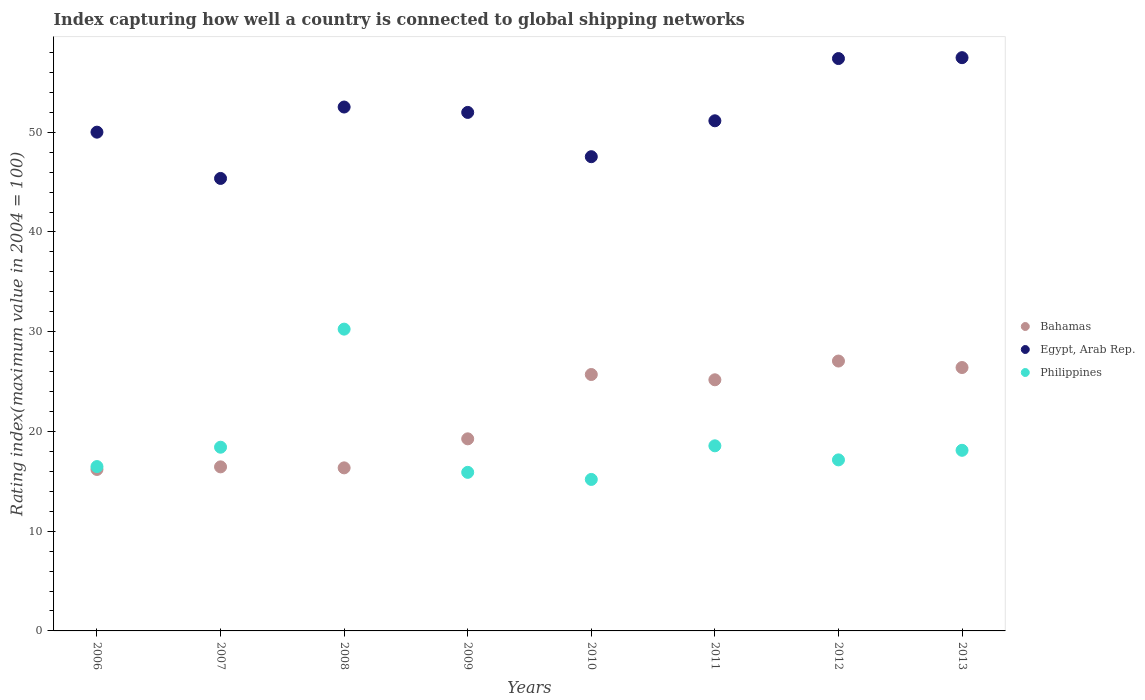What is the rating index in Philippines in 2006?
Your answer should be very brief. 16.48. Across all years, what is the maximum rating index in Bahamas?
Your answer should be compact. 27.06. Across all years, what is the minimum rating index in Philippines?
Your answer should be compact. 15.19. What is the total rating index in Philippines in the graph?
Your answer should be compact. 150.07. What is the difference between the rating index in Egypt, Arab Rep. in 2007 and that in 2010?
Make the answer very short. -2.18. What is the difference between the rating index in Philippines in 2011 and the rating index in Bahamas in 2010?
Make the answer very short. -7.15. What is the average rating index in Philippines per year?
Make the answer very short. 18.76. In the year 2011, what is the difference between the rating index in Philippines and rating index in Egypt, Arab Rep.?
Keep it short and to the point. -32.59. In how many years, is the rating index in Philippines greater than 30?
Give a very brief answer. 1. What is the ratio of the rating index in Philippines in 2007 to that in 2011?
Offer a terse response. 0.99. Is the rating index in Philippines in 2006 less than that in 2011?
Your response must be concise. Yes. Is the difference between the rating index in Philippines in 2008 and 2009 greater than the difference between the rating index in Egypt, Arab Rep. in 2008 and 2009?
Your answer should be compact. Yes. What is the difference between the highest and the second highest rating index in Philippines?
Provide a short and direct response. 11.7. What is the difference between the highest and the lowest rating index in Philippines?
Ensure brevity in your answer.  15.07. In how many years, is the rating index in Egypt, Arab Rep. greater than the average rating index in Egypt, Arab Rep. taken over all years?
Offer a very short reply. 4. Is it the case that in every year, the sum of the rating index in Egypt, Arab Rep. and rating index in Bahamas  is greater than the rating index in Philippines?
Keep it short and to the point. Yes. Does the rating index in Bahamas monotonically increase over the years?
Provide a short and direct response. No. What is the difference between two consecutive major ticks on the Y-axis?
Offer a terse response. 10. Does the graph contain any zero values?
Your response must be concise. No. Does the graph contain grids?
Provide a short and direct response. No. Where does the legend appear in the graph?
Make the answer very short. Center right. What is the title of the graph?
Provide a succinct answer. Index capturing how well a country is connected to global shipping networks. What is the label or title of the X-axis?
Ensure brevity in your answer.  Years. What is the label or title of the Y-axis?
Give a very brief answer. Rating index(maximum value in 2004 = 100). What is the Rating index(maximum value in 2004 = 100) of Bahamas in 2006?
Your response must be concise. 16.19. What is the Rating index(maximum value in 2004 = 100) in Egypt, Arab Rep. in 2006?
Provide a succinct answer. 50.01. What is the Rating index(maximum value in 2004 = 100) of Philippines in 2006?
Your answer should be very brief. 16.48. What is the Rating index(maximum value in 2004 = 100) in Bahamas in 2007?
Offer a very short reply. 16.45. What is the Rating index(maximum value in 2004 = 100) in Egypt, Arab Rep. in 2007?
Offer a terse response. 45.37. What is the Rating index(maximum value in 2004 = 100) of Philippines in 2007?
Your response must be concise. 18.42. What is the Rating index(maximum value in 2004 = 100) of Bahamas in 2008?
Provide a succinct answer. 16.35. What is the Rating index(maximum value in 2004 = 100) of Egypt, Arab Rep. in 2008?
Make the answer very short. 52.53. What is the Rating index(maximum value in 2004 = 100) of Philippines in 2008?
Provide a short and direct response. 30.26. What is the Rating index(maximum value in 2004 = 100) in Bahamas in 2009?
Provide a short and direct response. 19.26. What is the Rating index(maximum value in 2004 = 100) in Egypt, Arab Rep. in 2009?
Offer a very short reply. 51.99. What is the Rating index(maximum value in 2004 = 100) of Bahamas in 2010?
Provide a succinct answer. 25.71. What is the Rating index(maximum value in 2004 = 100) in Egypt, Arab Rep. in 2010?
Your response must be concise. 47.55. What is the Rating index(maximum value in 2004 = 100) of Philippines in 2010?
Ensure brevity in your answer.  15.19. What is the Rating index(maximum value in 2004 = 100) of Bahamas in 2011?
Keep it short and to the point. 25.18. What is the Rating index(maximum value in 2004 = 100) in Egypt, Arab Rep. in 2011?
Provide a short and direct response. 51.15. What is the Rating index(maximum value in 2004 = 100) of Philippines in 2011?
Ensure brevity in your answer.  18.56. What is the Rating index(maximum value in 2004 = 100) in Bahamas in 2012?
Your answer should be very brief. 27.06. What is the Rating index(maximum value in 2004 = 100) of Egypt, Arab Rep. in 2012?
Offer a very short reply. 57.39. What is the Rating index(maximum value in 2004 = 100) in Philippines in 2012?
Provide a succinct answer. 17.15. What is the Rating index(maximum value in 2004 = 100) in Bahamas in 2013?
Your answer should be compact. 26.41. What is the Rating index(maximum value in 2004 = 100) in Egypt, Arab Rep. in 2013?
Your response must be concise. 57.48. What is the Rating index(maximum value in 2004 = 100) in Philippines in 2013?
Offer a very short reply. 18.11. Across all years, what is the maximum Rating index(maximum value in 2004 = 100) of Bahamas?
Ensure brevity in your answer.  27.06. Across all years, what is the maximum Rating index(maximum value in 2004 = 100) of Egypt, Arab Rep.?
Your response must be concise. 57.48. Across all years, what is the maximum Rating index(maximum value in 2004 = 100) in Philippines?
Give a very brief answer. 30.26. Across all years, what is the minimum Rating index(maximum value in 2004 = 100) in Bahamas?
Provide a short and direct response. 16.19. Across all years, what is the minimum Rating index(maximum value in 2004 = 100) of Egypt, Arab Rep.?
Your response must be concise. 45.37. Across all years, what is the minimum Rating index(maximum value in 2004 = 100) in Philippines?
Offer a terse response. 15.19. What is the total Rating index(maximum value in 2004 = 100) in Bahamas in the graph?
Give a very brief answer. 172.61. What is the total Rating index(maximum value in 2004 = 100) of Egypt, Arab Rep. in the graph?
Keep it short and to the point. 413.47. What is the total Rating index(maximum value in 2004 = 100) of Philippines in the graph?
Offer a very short reply. 150.07. What is the difference between the Rating index(maximum value in 2004 = 100) in Bahamas in 2006 and that in 2007?
Give a very brief answer. -0.26. What is the difference between the Rating index(maximum value in 2004 = 100) of Egypt, Arab Rep. in 2006 and that in 2007?
Your answer should be compact. 4.64. What is the difference between the Rating index(maximum value in 2004 = 100) in Philippines in 2006 and that in 2007?
Your response must be concise. -1.94. What is the difference between the Rating index(maximum value in 2004 = 100) of Bahamas in 2006 and that in 2008?
Offer a terse response. -0.16. What is the difference between the Rating index(maximum value in 2004 = 100) in Egypt, Arab Rep. in 2006 and that in 2008?
Keep it short and to the point. -2.52. What is the difference between the Rating index(maximum value in 2004 = 100) of Philippines in 2006 and that in 2008?
Your answer should be compact. -13.78. What is the difference between the Rating index(maximum value in 2004 = 100) in Bahamas in 2006 and that in 2009?
Keep it short and to the point. -3.07. What is the difference between the Rating index(maximum value in 2004 = 100) in Egypt, Arab Rep. in 2006 and that in 2009?
Provide a succinct answer. -1.98. What is the difference between the Rating index(maximum value in 2004 = 100) of Philippines in 2006 and that in 2009?
Make the answer very short. 0.58. What is the difference between the Rating index(maximum value in 2004 = 100) in Bahamas in 2006 and that in 2010?
Make the answer very short. -9.52. What is the difference between the Rating index(maximum value in 2004 = 100) of Egypt, Arab Rep. in 2006 and that in 2010?
Offer a very short reply. 2.46. What is the difference between the Rating index(maximum value in 2004 = 100) of Philippines in 2006 and that in 2010?
Your response must be concise. 1.29. What is the difference between the Rating index(maximum value in 2004 = 100) of Bahamas in 2006 and that in 2011?
Your answer should be compact. -8.99. What is the difference between the Rating index(maximum value in 2004 = 100) in Egypt, Arab Rep. in 2006 and that in 2011?
Your response must be concise. -1.14. What is the difference between the Rating index(maximum value in 2004 = 100) of Philippines in 2006 and that in 2011?
Your answer should be compact. -2.08. What is the difference between the Rating index(maximum value in 2004 = 100) in Bahamas in 2006 and that in 2012?
Offer a very short reply. -10.87. What is the difference between the Rating index(maximum value in 2004 = 100) in Egypt, Arab Rep. in 2006 and that in 2012?
Make the answer very short. -7.38. What is the difference between the Rating index(maximum value in 2004 = 100) in Philippines in 2006 and that in 2012?
Offer a very short reply. -0.67. What is the difference between the Rating index(maximum value in 2004 = 100) of Bahamas in 2006 and that in 2013?
Your response must be concise. -10.22. What is the difference between the Rating index(maximum value in 2004 = 100) of Egypt, Arab Rep. in 2006 and that in 2013?
Keep it short and to the point. -7.47. What is the difference between the Rating index(maximum value in 2004 = 100) of Philippines in 2006 and that in 2013?
Provide a short and direct response. -1.63. What is the difference between the Rating index(maximum value in 2004 = 100) of Bahamas in 2007 and that in 2008?
Provide a succinct answer. 0.1. What is the difference between the Rating index(maximum value in 2004 = 100) of Egypt, Arab Rep. in 2007 and that in 2008?
Ensure brevity in your answer.  -7.16. What is the difference between the Rating index(maximum value in 2004 = 100) in Philippines in 2007 and that in 2008?
Keep it short and to the point. -11.84. What is the difference between the Rating index(maximum value in 2004 = 100) in Bahamas in 2007 and that in 2009?
Provide a short and direct response. -2.81. What is the difference between the Rating index(maximum value in 2004 = 100) of Egypt, Arab Rep. in 2007 and that in 2009?
Give a very brief answer. -6.62. What is the difference between the Rating index(maximum value in 2004 = 100) of Philippines in 2007 and that in 2009?
Keep it short and to the point. 2.52. What is the difference between the Rating index(maximum value in 2004 = 100) in Bahamas in 2007 and that in 2010?
Keep it short and to the point. -9.26. What is the difference between the Rating index(maximum value in 2004 = 100) of Egypt, Arab Rep. in 2007 and that in 2010?
Provide a short and direct response. -2.18. What is the difference between the Rating index(maximum value in 2004 = 100) in Philippines in 2007 and that in 2010?
Offer a very short reply. 3.23. What is the difference between the Rating index(maximum value in 2004 = 100) in Bahamas in 2007 and that in 2011?
Your answer should be compact. -8.73. What is the difference between the Rating index(maximum value in 2004 = 100) of Egypt, Arab Rep. in 2007 and that in 2011?
Your response must be concise. -5.78. What is the difference between the Rating index(maximum value in 2004 = 100) in Philippines in 2007 and that in 2011?
Offer a very short reply. -0.14. What is the difference between the Rating index(maximum value in 2004 = 100) of Bahamas in 2007 and that in 2012?
Make the answer very short. -10.61. What is the difference between the Rating index(maximum value in 2004 = 100) of Egypt, Arab Rep. in 2007 and that in 2012?
Your response must be concise. -12.02. What is the difference between the Rating index(maximum value in 2004 = 100) of Philippines in 2007 and that in 2012?
Keep it short and to the point. 1.27. What is the difference between the Rating index(maximum value in 2004 = 100) in Bahamas in 2007 and that in 2013?
Provide a succinct answer. -9.96. What is the difference between the Rating index(maximum value in 2004 = 100) of Egypt, Arab Rep. in 2007 and that in 2013?
Ensure brevity in your answer.  -12.11. What is the difference between the Rating index(maximum value in 2004 = 100) in Philippines in 2007 and that in 2013?
Your answer should be compact. 0.31. What is the difference between the Rating index(maximum value in 2004 = 100) in Bahamas in 2008 and that in 2009?
Offer a terse response. -2.91. What is the difference between the Rating index(maximum value in 2004 = 100) in Egypt, Arab Rep. in 2008 and that in 2009?
Provide a short and direct response. 0.54. What is the difference between the Rating index(maximum value in 2004 = 100) in Philippines in 2008 and that in 2009?
Offer a very short reply. 14.36. What is the difference between the Rating index(maximum value in 2004 = 100) in Bahamas in 2008 and that in 2010?
Provide a short and direct response. -9.36. What is the difference between the Rating index(maximum value in 2004 = 100) in Egypt, Arab Rep. in 2008 and that in 2010?
Give a very brief answer. 4.98. What is the difference between the Rating index(maximum value in 2004 = 100) in Philippines in 2008 and that in 2010?
Offer a terse response. 15.07. What is the difference between the Rating index(maximum value in 2004 = 100) of Bahamas in 2008 and that in 2011?
Ensure brevity in your answer.  -8.83. What is the difference between the Rating index(maximum value in 2004 = 100) of Egypt, Arab Rep. in 2008 and that in 2011?
Your answer should be compact. 1.38. What is the difference between the Rating index(maximum value in 2004 = 100) of Philippines in 2008 and that in 2011?
Your answer should be very brief. 11.7. What is the difference between the Rating index(maximum value in 2004 = 100) of Bahamas in 2008 and that in 2012?
Make the answer very short. -10.71. What is the difference between the Rating index(maximum value in 2004 = 100) of Egypt, Arab Rep. in 2008 and that in 2012?
Your answer should be very brief. -4.86. What is the difference between the Rating index(maximum value in 2004 = 100) of Philippines in 2008 and that in 2012?
Offer a terse response. 13.11. What is the difference between the Rating index(maximum value in 2004 = 100) of Bahamas in 2008 and that in 2013?
Keep it short and to the point. -10.06. What is the difference between the Rating index(maximum value in 2004 = 100) in Egypt, Arab Rep. in 2008 and that in 2013?
Your answer should be compact. -4.95. What is the difference between the Rating index(maximum value in 2004 = 100) of Philippines in 2008 and that in 2013?
Provide a succinct answer. 12.15. What is the difference between the Rating index(maximum value in 2004 = 100) of Bahamas in 2009 and that in 2010?
Give a very brief answer. -6.45. What is the difference between the Rating index(maximum value in 2004 = 100) of Egypt, Arab Rep. in 2009 and that in 2010?
Provide a succinct answer. 4.44. What is the difference between the Rating index(maximum value in 2004 = 100) of Philippines in 2009 and that in 2010?
Provide a succinct answer. 0.71. What is the difference between the Rating index(maximum value in 2004 = 100) in Bahamas in 2009 and that in 2011?
Your answer should be compact. -5.92. What is the difference between the Rating index(maximum value in 2004 = 100) in Egypt, Arab Rep. in 2009 and that in 2011?
Offer a very short reply. 0.84. What is the difference between the Rating index(maximum value in 2004 = 100) in Philippines in 2009 and that in 2011?
Offer a very short reply. -2.66. What is the difference between the Rating index(maximum value in 2004 = 100) in Bahamas in 2009 and that in 2012?
Make the answer very short. -7.8. What is the difference between the Rating index(maximum value in 2004 = 100) in Philippines in 2009 and that in 2012?
Keep it short and to the point. -1.25. What is the difference between the Rating index(maximum value in 2004 = 100) in Bahamas in 2009 and that in 2013?
Give a very brief answer. -7.15. What is the difference between the Rating index(maximum value in 2004 = 100) in Egypt, Arab Rep. in 2009 and that in 2013?
Provide a succinct answer. -5.49. What is the difference between the Rating index(maximum value in 2004 = 100) of Philippines in 2009 and that in 2013?
Ensure brevity in your answer.  -2.21. What is the difference between the Rating index(maximum value in 2004 = 100) of Bahamas in 2010 and that in 2011?
Give a very brief answer. 0.53. What is the difference between the Rating index(maximum value in 2004 = 100) of Egypt, Arab Rep. in 2010 and that in 2011?
Provide a succinct answer. -3.6. What is the difference between the Rating index(maximum value in 2004 = 100) of Philippines in 2010 and that in 2011?
Your response must be concise. -3.37. What is the difference between the Rating index(maximum value in 2004 = 100) of Bahamas in 2010 and that in 2012?
Your response must be concise. -1.35. What is the difference between the Rating index(maximum value in 2004 = 100) in Egypt, Arab Rep. in 2010 and that in 2012?
Your answer should be very brief. -9.84. What is the difference between the Rating index(maximum value in 2004 = 100) in Philippines in 2010 and that in 2012?
Make the answer very short. -1.96. What is the difference between the Rating index(maximum value in 2004 = 100) of Bahamas in 2010 and that in 2013?
Your answer should be compact. -0.7. What is the difference between the Rating index(maximum value in 2004 = 100) in Egypt, Arab Rep. in 2010 and that in 2013?
Offer a terse response. -9.93. What is the difference between the Rating index(maximum value in 2004 = 100) of Philippines in 2010 and that in 2013?
Keep it short and to the point. -2.92. What is the difference between the Rating index(maximum value in 2004 = 100) of Bahamas in 2011 and that in 2012?
Your response must be concise. -1.88. What is the difference between the Rating index(maximum value in 2004 = 100) of Egypt, Arab Rep. in 2011 and that in 2012?
Your answer should be compact. -6.24. What is the difference between the Rating index(maximum value in 2004 = 100) in Philippines in 2011 and that in 2012?
Offer a very short reply. 1.41. What is the difference between the Rating index(maximum value in 2004 = 100) of Bahamas in 2011 and that in 2013?
Your answer should be very brief. -1.23. What is the difference between the Rating index(maximum value in 2004 = 100) of Egypt, Arab Rep. in 2011 and that in 2013?
Ensure brevity in your answer.  -6.33. What is the difference between the Rating index(maximum value in 2004 = 100) of Philippines in 2011 and that in 2013?
Provide a short and direct response. 0.45. What is the difference between the Rating index(maximum value in 2004 = 100) of Bahamas in 2012 and that in 2013?
Your answer should be very brief. 0.65. What is the difference between the Rating index(maximum value in 2004 = 100) of Egypt, Arab Rep. in 2012 and that in 2013?
Your response must be concise. -0.09. What is the difference between the Rating index(maximum value in 2004 = 100) of Philippines in 2012 and that in 2013?
Your answer should be compact. -0.96. What is the difference between the Rating index(maximum value in 2004 = 100) of Bahamas in 2006 and the Rating index(maximum value in 2004 = 100) of Egypt, Arab Rep. in 2007?
Offer a terse response. -29.18. What is the difference between the Rating index(maximum value in 2004 = 100) of Bahamas in 2006 and the Rating index(maximum value in 2004 = 100) of Philippines in 2007?
Your answer should be very brief. -2.23. What is the difference between the Rating index(maximum value in 2004 = 100) of Egypt, Arab Rep. in 2006 and the Rating index(maximum value in 2004 = 100) of Philippines in 2007?
Your answer should be compact. 31.59. What is the difference between the Rating index(maximum value in 2004 = 100) in Bahamas in 2006 and the Rating index(maximum value in 2004 = 100) in Egypt, Arab Rep. in 2008?
Make the answer very short. -36.34. What is the difference between the Rating index(maximum value in 2004 = 100) in Bahamas in 2006 and the Rating index(maximum value in 2004 = 100) in Philippines in 2008?
Make the answer very short. -14.07. What is the difference between the Rating index(maximum value in 2004 = 100) in Egypt, Arab Rep. in 2006 and the Rating index(maximum value in 2004 = 100) in Philippines in 2008?
Offer a terse response. 19.75. What is the difference between the Rating index(maximum value in 2004 = 100) in Bahamas in 2006 and the Rating index(maximum value in 2004 = 100) in Egypt, Arab Rep. in 2009?
Give a very brief answer. -35.8. What is the difference between the Rating index(maximum value in 2004 = 100) of Bahamas in 2006 and the Rating index(maximum value in 2004 = 100) of Philippines in 2009?
Your answer should be compact. 0.29. What is the difference between the Rating index(maximum value in 2004 = 100) of Egypt, Arab Rep. in 2006 and the Rating index(maximum value in 2004 = 100) of Philippines in 2009?
Ensure brevity in your answer.  34.11. What is the difference between the Rating index(maximum value in 2004 = 100) of Bahamas in 2006 and the Rating index(maximum value in 2004 = 100) of Egypt, Arab Rep. in 2010?
Your response must be concise. -31.36. What is the difference between the Rating index(maximum value in 2004 = 100) of Egypt, Arab Rep. in 2006 and the Rating index(maximum value in 2004 = 100) of Philippines in 2010?
Ensure brevity in your answer.  34.82. What is the difference between the Rating index(maximum value in 2004 = 100) in Bahamas in 2006 and the Rating index(maximum value in 2004 = 100) in Egypt, Arab Rep. in 2011?
Your response must be concise. -34.96. What is the difference between the Rating index(maximum value in 2004 = 100) in Bahamas in 2006 and the Rating index(maximum value in 2004 = 100) in Philippines in 2011?
Keep it short and to the point. -2.37. What is the difference between the Rating index(maximum value in 2004 = 100) in Egypt, Arab Rep. in 2006 and the Rating index(maximum value in 2004 = 100) in Philippines in 2011?
Ensure brevity in your answer.  31.45. What is the difference between the Rating index(maximum value in 2004 = 100) of Bahamas in 2006 and the Rating index(maximum value in 2004 = 100) of Egypt, Arab Rep. in 2012?
Your answer should be compact. -41.2. What is the difference between the Rating index(maximum value in 2004 = 100) in Bahamas in 2006 and the Rating index(maximum value in 2004 = 100) in Philippines in 2012?
Offer a very short reply. -0.96. What is the difference between the Rating index(maximum value in 2004 = 100) of Egypt, Arab Rep. in 2006 and the Rating index(maximum value in 2004 = 100) of Philippines in 2012?
Your answer should be very brief. 32.86. What is the difference between the Rating index(maximum value in 2004 = 100) in Bahamas in 2006 and the Rating index(maximum value in 2004 = 100) in Egypt, Arab Rep. in 2013?
Ensure brevity in your answer.  -41.29. What is the difference between the Rating index(maximum value in 2004 = 100) of Bahamas in 2006 and the Rating index(maximum value in 2004 = 100) of Philippines in 2013?
Make the answer very short. -1.92. What is the difference between the Rating index(maximum value in 2004 = 100) of Egypt, Arab Rep. in 2006 and the Rating index(maximum value in 2004 = 100) of Philippines in 2013?
Provide a short and direct response. 31.9. What is the difference between the Rating index(maximum value in 2004 = 100) in Bahamas in 2007 and the Rating index(maximum value in 2004 = 100) in Egypt, Arab Rep. in 2008?
Your answer should be compact. -36.08. What is the difference between the Rating index(maximum value in 2004 = 100) in Bahamas in 2007 and the Rating index(maximum value in 2004 = 100) in Philippines in 2008?
Provide a short and direct response. -13.81. What is the difference between the Rating index(maximum value in 2004 = 100) of Egypt, Arab Rep. in 2007 and the Rating index(maximum value in 2004 = 100) of Philippines in 2008?
Provide a short and direct response. 15.11. What is the difference between the Rating index(maximum value in 2004 = 100) in Bahamas in 2007 and the Rating index(maximum value in 2004 = 100) in Egypt, Arab Rep. in 2009?
Your answer should be very brief. -35.54. What is the difference between the Rating index(maximum value in 2004 = 100) in Bahamas in 2007 and the Rating index(maximum value in 2004 = 100) in Philippines in 2009?
Provide a succinct answer. 0.55. What is the difference between the Rating index(maximum value in 2004 = 100) in Egypt, Arab Rep. in 2007 and the Rating index(maximum value in 2004 = 100) in Philippines in 2009?
Give a very brief answer. 29.47. What is the difference between the Rating index(maximum value in 2004 = 100) in Bahamas in 2007 and the Rating index(maximum value in 2004 = 100) in Egypt, Arab Rep. in 2010?
Your answer should be compact. -31.1. What is the difference between the Rating index(maximum value in 2004 = 100) of Bahamas in 2007 and the Rating index(maximum value in 2004 = 100) of Philippines in 2010?
Offer a very short reply. 1.26. What is the difference between the Rating index(maximum value in 2004 = 100) in Egypt, Arab Rep. in 2007 and the Rating index(maximum value in 2004 = 100) in Philippines in 2010?
Your answer should be compact. 30.18. What is the difference between the Rating index(maximum value in 2004 = 100) of Bahamas in 2007 and the Rating index(maximum value in 2004 = 100) of Egypt, Arab Rep. in 2011?
Provide a short and direct response. -34.7. What is the difference between the Rating index(maximum value in 2004 = 100) in Bahamas in 2007 and the Rating index(maximum value in 2004 = 100) in Philippines in 2011?
Make the answer very short. -2.11. What is the difference between the Rating index(maximum value in 2004 = 100) in Egypt, Arab Rep. in 2007 and the Rating index(maximum value in 2004 = 100) in Philippines in 2011?
Keep it short and to the point. 26.81. What is the difference between the Rating index(maximum value in 2004 = 100) of Bahamas in 2007 and the Rating index(maximum value in 2004 = 100) of Egypt, Arab Rep. in 2012?
Your answer should be very brief. -40.94. What is the difference between the Rating index(maximum value in 2004 = 100) of Egypt, Arab Rep. in 2007 and the Rating index(maximum value in 2004 = 100) of Philippines in 2012?
Your answer should be very brief. 28.22. What is the difference between the Rating index(maximum value in 2004 = 100) of Bahamas in 2007 and the Rating index(maximum value in 2004 = 100) of Egypt, Arab Rep. in 2013?
Offer a terse response. -41.03. What is the difference between the Rating index(maximum value in 2004 = 100) of Bahamas in 2007 and the Rating index(maximum value in 2004 = 100) of Philippines in 2013?
Your answer should be very brief. -1.66. What is the difference between the Rating index(maximum value in 2004 = 100) of Egypt, Arab Rep. in 2007 and the Rating index(maximum value in 2004 = 100) of Philippines in 2013?
Your answer should be very brief. 27.26. What is the difference between the Rating index(maximum value in 2004 = 100) in Bahamas in 2008 and the Rating index(maximum value in 2004 = 100) in Egypt, Arab Rep. in 2009?
Keep it short and to the point. -35.64. What is the difference between the Rating index(maximum value in 2004 = 100) in Bahamas in 2008 and the Rating index(maximum value in 2004 = 100) in Philippines in 2009?
Provide a short and direct response. 0.45. What is the difference between the Rating index(maximum value in 2004 = 100) of Egypt, Arab Rep. in 2008 and the Rating index(maximum value in 2004 = 100) of Philippines in 2009?
Your answer should be compact. 36.63. What is the difference between the Rating index(maximum value in 2004 = 100) in Bahamas in 2008 and the Rating index(maximum value in 2004 = 100) in Egypt, Arab Rep. in 2010?
Make the answer very short. -31.2. What is the difference between the Rating index(maximum value in 2004 = 100) in Bahamas in 2008 and the Rating index(maximum value in 2004 = 100) in Philippines in 2010?
Your response must be concise. 1.16. What is the difference between the Rating index(maximum value in 2004 = 100) of Egypt, Arab Rep. in 2008 and the Rating index(maximum value in 2004 = 100) of Philippines in 2010?
Offer a terse response. 37.34. What is the difference between the Rating index(maximum value in 2004 = 100) of Bahamas in 2008 and the Rating index(maximum value in 2004 = 100) of Egypt, Arab Rep. in 2011?
Give a very brief answer. -34.8. What is the difference between the Rating index(maximum value in 2004 = 100) in Bahamas in 2008 and the Rating index(maximum value in 2004 = 100) in Philippines in 2011?
Your answer should be very brief. -2.21. What is the difference between the Rating index(maximum value in 2004 = 100) in Egypt, Arab Rep. in 2008 and the Rating index(maximum value in 2004 = 100) in Philippines in 2011?
Make the answer very short. 33.97. What is the difference between the Rating index(maximum value in 2004 = 100) in Bahamas in 2008 and the Rating index(maximum value in 2004 = 100) in Egypt, Arab Rep. in 2012?
Make the answer very short. -41.04. What is the difference between the Rating index(maximum value in 2004 = 100) of Bahamas in 2008 and the Rating index(maximum value in 2004 = 100) of Philippines in 2012?
Your response must be concise. -0.8. What is the difference between the Rating index(maximum value in 2004 = 100) in Egypt, Arab Rep. in 2008 and the Rating index(maximum value in 2004 = 100) in Philippines in 2012?
Ensure brevity in your answer.  35.38. What is the difference between the Rating index(maximum value in 2004 = 100) in Bahamas in 2008 and the Rating index(maximum value in 2004 = 100) in Egypt, Arab Rep. in 2013?
Ensure brevity in your answer.  -41.13. What is the difference between the Rating index(maximum value in 2004 = 100) in Bahamas in 2008 and the Rating index(maximum value in 2004 = 100) in Philippines in 2013?
Provide a short and direct response. -1.76. What is the difference between the Rating index(maximum value in 2004 = 100) in Egypt, Arab Rep. in 2008 and the Rating index(maximum value in 2004 = 100) in Philippines in 2013?
Provide a short and direct response. 34.42. What is the difference between the Rating index(maximum value in 2004 = 100) in Bahamas in 2009 and the Rating index(maximum value in 2004 = 100) in Egypt, Arab Rep. in 2010?
Give a very brief answer. -28.29. What is the difference between the Rating index(maximum value in 2004 = 100) of Bahamas in 2009 and the Rating index(maximum value in 2004 = 100) of Philippines in 2010?
Offer a very short reply. 4.07. What is the difference between the Rating index(maximum value in 2004 = 100) of Egypt, Arab Rep. in 2009 and the Rating index(maximum value in 2004 = 100) of Philippines in 2010?
Your response must be concise. 36.8. What is the difference between the Rating index(maximum value in 2004 = 100) in Bahamas in 2009 and the Rating index(maximum value in 2004 = 100) in Egypt, Arab Rep. in 2011?
Make the answer very short. -31.89. What is the difference between the Rating index(maximum value in 2004 = 100) of Egypt, Arab Rep. in 2009 and the Rating index(maximum value in 2004 = 100) of Philippines in 2011?
Your answer should be compact. 33.43. What is the difference between the Rating index(maximum value in 2004 = 100) in Bahamas in 2009 and the Rating index(maximum value in 2004 = 100) in Egypt, Arab Rep. in 2012?
Keep it short and to the point. -38.13. What is the difference between the Rating index(maximum value in 2004 = 100) of Bahamas in 2009 and the Rating index(maximum value in 2004 = 100) of Philippines in 2012?
Give a very brief answer. 2.11. What is the difference between the Rating index(maximum value in 2004 = 100) of Egypt, Arab Rep. in 2009 and the Rating index(maximum value in 2004 = 100) of Philippines in 2012?
Ensure brevity in your answer.  34.84. What is the difference between the Rating index(maximum value in 2004 = 100) in Bahamas in 2009 and the Rating index(maximum value in 2004 = 100) in Egypt, Arab Rep. in 2013?
Ensure brevity in your answer.  -38.22. What is the difference between the Rating index(maximum value in 2004 = 100) of Bahamas in 2009 and the Rating index(maximum value in 2004 = 100) of Philippines in 2013?
Make the answer very short. 1.15. What is the difference between the Rating index(maximum value in 2004 = 100) of Egypt, Arab Rep. in 2009 and the Rating index(maximum value in 2004 = 100) of Philippines in 2013?
Keep it short and to the point. 33.88. What is the difference between the Rating index(maximum value in 2004 = 100) in Bahamas in 2010 and the Rating index(maximum value in 2004 = 100) in Egypt, Arab Rep. in 2011?
Ensure brevity in your answer.  -25.44. What is the difference between the Rating index(maximum value in 2004 = 100) in Bahamas in 2010 and the Rating index(maximum value in 2004 = 100) in Philippines in 2011?
Your answer should be compact. 7.15. What is the difference between the Rating index(maximum value in 2004 = 100) in Egypt, Arab Rep. in 2010 and the Rating index(maximum value in 2004 = 100) in Philippines in 2011?
Give a very brief answer. 28.99. What is the difference between the Rating index(maximum value in 2004 = 100) of Bahamas in 2010 and the Rating index(maximum value in 2004 = 100) of Egypt, Arab Rep. in 2012?
Your answer should be compact. -31.68. What is the difference between the Rating index(maximum value in 2004 = 100) in Bahamas in 2010 and the Rating index(maximum value in 2004 = 100) in Philippines in 2012?
Keep it short and to the point. 8.56. What is the difference between the Rating index(maximum value in 2004 = 100) in Egypt, Arab Rep. in 2010 and the Rating index(maximum value in 2004 = 100) in Philippines in 2012?
Offer a very short reply. 30.4. What is the difference between the Rating index(maximum value in 2004 = 100) in Bahamas in 2010 and the Rating index(maximum value in 2004 = 100) in Egypt, Arab Rep. in 2013?
Give a very brief answer. -31.77. What is the difference between the Rating index(maximum value in 2004 = 100) of Egypt, Arab Rep. in 2010 and the Rating index(maximum value in 2004 = 100) of Philippines in 2013?
Provide a succinct answer. 29.44. What is the difference between the Rating index(maximum value in 2004 = 100) of Bahamas in 2011 and the Rating index(maximum value in 2004 = 100) of Egypt, Arab Rep. in 2012?
Offer a terse response. -32.21. What is the difference between the Rating index(maximum value in 2004 = 100) of Bahamas in 2011 and the Rating index(maximum value in 2004 = 100) of Philippines in 2012?
Keep it short and to the point. 8.03. What is the difference between the Rating index(maximum value in 2004 = 100) in Egypt, Arab Rep. in 2011 and the Rating index(maximum value in 2004 = 100) in Philippines in 2012?
Give a very brief answer. 34. What is the difference between the Rating index(maximum value in 2004 = 100) in Bahamas in 2011 and the Rating index(maximum value in 2004 = 100) in Egypt, Arab Rep. in 2013?
Make the answer very short. -32.3. What is the difference between the Rating index(maximum value in 2004 = 100) in Bahamas in 2011 and the Rating index(maximum value in 2004 = 100) in Philippines in 2013?
Make the answer very short. 7.07. What is the difference between the Rating index(maximum value in 2004 = 100) of Egypt, Arab Rep. in 2011 and the Rating index(maximum value in 2004 = 100) of Philippines in 2013?
Offer a terse response. 33.04. What is the difference between the Rating index(maximum value in 2004 = 100) in Bahamas in 2012 and the Rating index(maximum value in 2004 = 100) in Egypt, Arab Rep. in 2013?
Your response must be concise. -30.42. What is the difference between the Rating index(maximum value in 2004 = 100) in Bahamas in 2012 and the Rating index(maximum value in 2004 = 100) in Philippines in 2013?
Offer a very short reply. 8.95. What is the difference between the Rating index(maximum value in 2004 = 100) of Egypt, Arab Rep. in 2012 and the Rating index(maximum value in 2004 = 100) of Philippines in 2013?
Your response must be concise. 39.28. What is the average Rating index(maximum value in 2004 = 100) of Bahamas per year?
Offer a very short reply. 21.58. What is the average Rating index(maximum value in 2004 = 100) of Egypt, Arab Rep. per year?
Your response must be concise. 51.68. What is the average Rating index(maximum value in 2004 = 100) of Philippines per year?
Give a very brief answer. 18.76. In the year 2006, what is the difference between the Rating index(maximum value in 2004 = 100) of Bahamas and Rating index(maximum value in 2004 = 100) of Egypt, Arab Rep.?
Your answer should be compact. -33.82. In the year 2006, what is the difference between the Rating index(maximum value in 2004 = 100) of Bahamas and Rating index(maximum value in 2004 = 100) of Philippines?
Provide a short and direct response. -0.29. In the year 2006, what is the difference between the Rating index(maximum value in 2004 = 100) in Egypt, Arab Rep. and Rating index(maximum value in 2004 = 100) in Philippines?
Give a very brief answer. 33.53. In the year 2007, what is the difference between the Rating index(maximum value in 2004 = 100) in Bahamas and Rating index(maximum value in 2004 = 100) in Egypt, Arab Rep.?
Give a very brief answer. -28.92. In the year 2007, what is the difference between the Rating index(maximum value in 2004 = 100) in Bahamas and Rating index(maximum value in 2004 = 100) in Philippines?
Your response must be concise. -1.97. In the year 2007, what is the difference between the Rating index(maximum value in 2004 = 100) in Egypt, Arab Rep. and Rating index(maximum value in 2004 = 100) in Philippines?
Keep it short and to the point. 26.95. In the year 2008, what is the difference between the Rating index(maximum value in 2004 = 100) of Bahamas and Rating index(maximum value in 2004 = 100) of Egypt, Arab Rep.?
Offer a terse response. -36.18. In the year 2008, what is the difference between the Rating index(maximum value in 2004 = 100) of Bahamas and Rating index(maximum value in 2004 = 100) of Philippines?
Offer a very short reply. -13.91. In the year 2008, what is the difference between the Rating index(maximum value in 2004 = 100) of Egypt, Arab Rep. and Rating index(maximum value in 2004 = 100) of Philippines?
Offer a terse response. 22.27. In the year 2009, what is the difference between the Rating index(maximum value in 2004 = 100) of Bahamas and Rating index(maximum value in 2004 = 100) of Egypt, Arab Rep.?
Your answer should be very brief. -32.73. In the year 2009, what is the difference between the Rating index(maximum value in 2004 = 100) in Bahamas and Rating index(maximum value in 2004 = 100) in Philippines?
Provide a short and direct response. 3.36. In the year 2009, what is the difference between the Rating index(maximum value in 2004 = 100) of Egypt, Arab Rep. and Rating index(maximum value in 2004 = 100) of Philippines?
Offer a very short reply. 36.09. In the year 2010, what is the difference between the Rating index(maximum value in 2004 = 100) of Bahamas and Rating index(maximum value in 2004 = 100) of Egypt, Arab Rep.?
Make the answer very short. -21.84. In the year 2010, what is the difference between the Rating index(maximum value in 2004 = 100) of Bahamas and Rating index(maximum value in 2004 = 100) of Philippines?
Your response must be concise. 10.52. In the year 2010, what is the difference between the Rating index(maximum value in 2004 = 100) in Egypt, Arab Rep. and Rating index(maximum value in 2004 = 100) in Philippines?
Offer a terse response. 32.36. In the year 2011, what is the difference between the Rating index(maximum value in 2004 = 100) of Bahamas and Rating index(maximum value in 2004 = 100) of Egypt, Arab Rep.?
Your answer should be very brief. -25.97. In the year 2011, what is the difference between the Rating index(maximum value in 2004 = 100) in Bahamas and Rating index(maximum value in 2004 = 100) in Philippines?
Keep it short and to the point. 6.62. In the year 2011, what is the difference between the Rating index(maximum value in 2004 = 100) in Egypt, Arab Rep. and Rating index(maximum value in 2004 = 100) in Philippines?
Offer a terse response. 32.59. In the year 2012, what is the difference between the Rating index(maximum value in 2004 = 100) in Bahamas and Rating index(maximum value in 2004 = 100) in Egypt, Arab Rep.?
Provide a succinct answer. -30.33. In the year 2012, what is the difference between the Rating index(maximum value in 2004 = 100) of Bahamas and Rating index(maximum value in 2004 = 100) of Philippines?
Offer a terse response. 9.91. In the year 2012, what is the difference between the Rating index(maximum value in 2004 = 100) in Egypt, Arab Rep. and Rating index(maximum value in 2004 = 100) in Philippines?
Your response must be concise. 40.24. In the year 2013, what is the difference between the Rating index(maximum value in 2004 = 100) of Bahamas and Rating index(maximum value in 2004 = 100) of Egypt, Arab Rep.?
Offer a very short reply. -31.07. In the year 2013, what is the difference between the Rating index(maximum value in 2004 = 100) in Egypt, Arab Rep. and Rating index(maximum value in 2004 = 100) in Philippines?
Give a very brief answer. 39.37. What is the ratio of the Rating index(maximum value in 2004 = 100) in Bahamas in 2006 to that in 2007?
Your answer should be very brief. 0.98. What is the ratio of the Rating index(maximum value in 2004 = 100) of Egypt, Arab Rep. in 2006 to that in 2007?
Your response must be concise. 1.1. What is the ratio of the Rating index(maximum value in 2004 = 100) in Philippines in 2006 to that in 2007?
Offer a terse response. 0.89. What is the ratio of the Rating index(maximum value in 2004 = 100) in Bahamas in 2006 to that in 2008?
Offer a terse response. 0.99. What is the ratio of the Rating index(maximum value in 2004 = 100) of Egypt, Arab Rep. in 2006 to that in 2008?
Your response must be concise. 0.95. What is the ratio of the Rating index(maximum value in 2004 = 100) of Philippines in 2006 to that in 2008?
Ensure brevity in your answer.  0.54. What is the ratio of the Rating index(maximum value in 2004 = 100) of Bahamas in 2006 to that in 2009?
Provide a short and direct response. 0.84. What is the ratio of the Rating index(maximum value in 2004 = 100) in Egypt, Arab Rep. in 2006 to that in 2009?
Provide a short and direct response. 0.96. What is the ratio of the Rating index(maximum value in 2004 = 100) in Philippines in 2006 to that in 2009?
Your answer should be compact. 1.04. What is the ratio of the Rating index(maximum value in 2004 = 100) of Bahamas in 2006 to that in 2010?
Provide a succinct answer. 0.63. What is the ratio of the Rating index(maximum value in 2004 = 100) of Egypt, Arab Rep. in 2006 to that in 2010?
Provide a succinct answer. 1.05. What is the ratio of the Rating index(maximum value in 2004 = 100) in Philippines in 2006 to that in 2010?
Ensure brevity in your answer.  1.08. What is the ratio of the Rating index(maximum value in 2004 = 100) in Bahamas in 2006 to that in 2011?
Keep it short and to the point. 0.64. What is the ratio of the Rating index(maximum value in 2004 = 100) in Egypt, Arab Rep. in 2006 to that in 2011?
Keep it short and to the point. 0.98. What is the ratio of the Rating index(maximum value in 2004 = 100) of Philippines in 2006 to that in 2011?
Give a very brief answer. 0.89. What is the ratio of the Rating index(maximum value in 2004 = 100) of Bahamas in 2006 to that in 2012?
Keep it short and to the point. 0.6. What is the ratio of the Rating index(maximum value in 2004 = 100) in Egypt, Arab Rep. in 2006 to that in 2012?
Give a very brief answer. 0.87. What is the ratio of the Rating index(maximum value in 2004 = 100) in Philippines in 2006 to that in 2012?
Offer a very short reply. 0.96. What is the ratio of the Rating index(maximum value in 2004 = 100) of Bahamas in 2006 to that in 2013?
Provide a succinct answer. 0.61. What is the ratio of the Rating index(maximum value in 2004 = 100) in Egypt, Arab Rep. in 2006 to that in 2013?
Offer a very short reply. 0.87. What is the ratio of the Rating index(maximum value in 2004 = 100) of Philippines in 2006 to that in 2013?
Your response must be concise. 0.91. What is the ratio of the Rating index(maximum value in 2004 = 100) of Bahamas in 2007 to that in 2008?
Keep it short and to the point. 1.01. What is the ratio of the Rating index(maximum value in 2004 = 100) of Egypt, Arab Rep. in 2007 to that in 2008?
Your response must be concise. 0.86. What is the ratio of the Rating index(maximum value in 2004 = 100) of Philippines in 2007 to that in 2008?
Your response must be concise. 0.61. What is the ratio of the Rating index(maximum value in 2004 = 100) in Bahamas in 2007 to that in 2009?
Provide a short and direct response. 0.85. What is the ratio of the Rating index(maximum value in 2004 = 100) in Egypt, Arab Rep. in 2007 to that in 2009?
Keep it short and to the point. 0.87. What is the ratio of the Rating index(maximum value in 2004 = 100) of Philippines in 2007 to that in 2009?
Provide a short and direct response. 1.16. What is the ratio of the Rating index(maximum value in 2004 = 100) of Bahamas in 2007 to that in 2010?
Offer a terse response. 0.64. What is the ratio of the Rating index(maximum value in 2004 = 100) of Egypt, Arab Rep. in 2007 to that in 2010?
Your answer should be very brief. 0.95. What is the ratio of the Rating index(maximum value in 2004 = 100) of Philippines in 2007 to that in 2010?
Provide a short and direct response. 1.21. What is the ratio of the Rating index(maximum value in 2004 = 100) of Bahamas in 2007 to that in 2011?
Make the answer very short. 0.65. What is the ratio of the Rating index(maximum value in 2004 = 100) of Egypt, Arab Rep. in 2007 to that in 2011?
Offer a terse response. 0.89. What is the ratio of the Rating index(maximum value in 2004 = 100) of Philippines in 2007 to that in 2011?
Offer a terse response. 0.99. What is the ratio of the Rating index(maximum value in 2004 = 100) of Bahamas in 2007 to that in 2012?
Provide a succinct answer. 0.61. What is the ratio of the Rating index(maximum value in 2004 = 100) in Egypt, Arab Rep. in 2007 to that in 2012?
Ensure brevity in your answer.  0.79. What is the ratio of the Rating index(maximum value in 2004 = 100) of Philippines in 2007 to that in 2012?
Give a very brief answer. 1.07. What is the ratio of the Rating index(maximum value in 2004 = 100) in Bahamas in 2007 to that in 2013?
Your answer should be compact. 0.62. What is the ratio of the Rating index(maximum value in 2004 = 100) in Egypt, Arab Rep. in 2007 to that in 2013?
Give a very brief answer. 0.79. What is the ratio of the Rating index(maximum value in 2004 = 100) of Philippines in 2007 to that in 2013?
Give a very brief answer. 1.02. What is the ratio of the Rating index(maximum value in 2004 = 100) in Bahamas in 2008 to that in 2009?
Provide a succinct answer. 0.85. What is the ratio of the Rating index(maximum value in 2004 = 100) of Egypt, Arab Rep. in 2008 to that in 2009?
Your answer should be compact. 1.01. What is the ratio of the Rating index(maximum value in 2004 = 100) of Philippines in 2008 to that in 2009?
Offer a terse response. 1.9. What is the ratio of the Rating index(maximum value in 2004 = 100) in Bahamas in 2008 to that in 2010?
Make the answer very short. 0.64. What is the ratio of the Rating index(maximum value in 2004 = 100) in Egypt, Arab Rep. in 2008 to that in 2010?
Make the answer very short. 1.1. What is the ratio of the Rating index(maximum value in 2004 = 100) of Philippines in 2008 to that in 2010?
Keep it short and to the point. 1.99. What is the ratio of the Rating index(maximum value in 2004 = 100) of Bahamas in 2008 to that in 2011?
Give a very brief answer. 0.65. What is the ratio of the Rating index(maximum value in 2004 = 100) in Egypt, Arab Rep. in 2008 to that in 2011?
Provide a succinct answer. 1.03. What is the ratio of the Rating index(maximum value in 2004 = 100) in Philippines in 2008 to that in 2011?
Offer a very short reply. 1.63. What is the ratio of the Rating index(maximum value in 2004 = 100) in Bahamas in 2008 to that in 2012?
Give a very brief answer. 0.6. What is the ratio of the Rating index(maximum value in 2004 = 100) in Egypt, Arab Rep. in 2008 to that in 2012?
Provide a succinct answer. 0.92. What is the ratio of the Rating index(maximum value in 2004 = 100) of Philippines in 2008 to that in 2012?
Ensure brevity in your answer.  1.76. What is the ratio of the Rating index(maximum value in 2004 = 100) of Bahamas in 2008 to that in 2013?
Make the answer very short. 0.62. What is the ratio of the Rating index(maximum value in 2004 = 100) in Egypt, Arab Rep. in 2008 to that in 2013?
Provide a short and direct response. 0.91. What is the ratio of the Rating index(maximum value in 2004 = 100) in Philippines in 2008 to that in 2013?
Provide a succinct answer. 1.67. What is the ratio of the Rating index(maximum value in 2004 = 100) in Bahamas in 2009 to that in 2010?
Provide a succinct answer. 0.75. What is the ratio of the Rating index(maximum value in 2004 = 100) of Egypt, Arab Rep. in 2009 to that in 2010?
Offer a terse response. 1.09. What is the ratio of the Rating index(maximum value in 2004 = 100) in Philippines in 2009 to that in 2010?
Your response must be concise. 1.05. What is the ratio of the Rating index(maximum value in 2004 = 100) in Bahamas in 2009 to that in 2011?
Your response must be concise. 0.76. What is the ratio of the Rating index(maximum value in 2004 = 100) of Egypt, Arab Rep. in 2009 to that in 2011?
Provide a succinct answer. 1.02. What is the ratio of the Rating index(maximum value in 2004 = 100) in Philippines in 2009 to that in 2011?
Your answer should be compact. 0.86. What is the ratio of the Rating index(maximum value in 2004 = 100) of Bahamas in 2009 to that in 2012?
Provide a short and direct response. 0.71. What is the ratio of the Rating index(maximum value in 2004 = 100) of Egypt, Arab Rep. in 2009 to that in 2012?
Offer a very short reply. 0.91. What is the ratio of the Rating index(maximum value in 2004 = 100) of Philippines in 2009 to that in 2012?
Offer a very short reply. 0.93. What is the ratio of the Rating index(maximum value in 2004 = 100) of Bahamas in 2009 to that in 2013?
Keep it short and to the point. 0.73. What is the ratio of the Rating index(maximum value in 2004 = 100) in Egypt, Arab Rep. in 2009 to that in 2013?
Keep it short and to the point. 0.9. What is the ratio of the Rating index(maximum value in 2004 = 100) in Philippines in 2009 to that in 2013?
Ensure brevity in your answer.  0.88. What is the ratio of the Rating index(maximum value in 2004 = 100) in Bahamas in 2010 to that in 2011?
Make the answer very short. 1.02. What is the ratio of the Rating index(maximum value in 2004 = 100) of Egypt, Arab Rep. in 2010 to that in 2011?
Make the answer very short. 0.93. What is the ratio of the Rating index(maximum value in 2004 = 100) of Philippines in 2010 to that in 2011?
Provide a short and direct response. 0.82. What is the ratio of the Rating index(maximum value in 2004 = 100) in Bahamas in 2010 to that in 2012?
Provide a short and direct response. 0.95. What is the ratio of the Rating index(maximum value in 2004 = 100) in Egypt, Arab Rep. in 2010 to that in 2012?
Provide a short and direct response. 0.83. What is the ratio of the Rating index(maximum value in 2004 = 100) of Philippines in 2010 to that in 2012?
Provide a short and direct response. 0.89. What is the ratio of the Rating index(maximum value in 2004 = 100) of Bahamas in 2010 to that in 2013?
Provide a succinct answer. 0.97. What is the ratio of the Rating index(maximum value in 2004 = 100) in Egypt, Arab Rep. in 2010 to that in 2013?
Keep it short and to the point. 0.83. What is the ratio of the Rating index(maximum value in 2004 = 100) of Philippines in 2010 to that in 2013?
Your response must be concise. 0.84. What is the ratio of the Rating index(maximum value in 2004 = 100) of Bahamas in 2011 to that in 2012?
Your response must be concise. 0.93. What is the ratio of the Rating index(maximum value in 2004 = 100) of Egypt, Arab Rep. in 2011 to that in 2012?
Keep it short and to the point. 0.89. What is the ratio of the Rating index(maximum value in 2004 = 100) of Philippines in 2011 to that in 2012?
Ensure brevity in your answer.  1.08. What is the ratio of the Rating index(maximum value in 2004 = 100) in Bahamas in 2011 to that in 2013?
Offer a very short reply. 0.95. What is the ratio of the Rating index(maximum value in 2004 = 100) of Egypt, Arab Rep. in 2011 to that in 2013?
Keep it short and to the point. 0.89. What is the ratio of the Rating index(maximum value in 2004 = 100) of Philippines in 2011 to that in 2013?
Provide a succinct answer. 1.02. What is the ratio of the Rating index(maximum value in 2004 = 100) of Bahamas in 2012 to that in 2013?
Ensure brevity in your answer.  1.02. What is the ratio of the Rating index(maximum value in 2004 = 100) in Egypt, Arab Rep. in 2012 to that in 2013?
Give a very brief answer. 1. What is the ratio of the Rating index(maximum value in 2004 = 100) in Philippines in 2012 to that in 2013?
Your answer should be very brief. 0.95. What is the difference between the highest and the second highest Rating index(maximum value in 2004 = 100) of Bahamas?
Make the answer very short. 0.65. What is the difference between the highest and the second highest Rating index(maximum value in 2004 = 100) of Egypt, Arab Rep.?
Give a very brief answer. 0.09. What is the difference between the highest and the second highest Rating index(maximum value in 2004 = 100) in Philippines?
Your answer should be compact. 11.7. What is the difference between the highest and the lowest Rating index(maximum value in 2004 = 100) of Bahamas?
Ensure brevity in your answer.  10.87. What is the difference between the highest and the lowest Rating index(maximum value in 2004 = 100) of Egypt, Arab Rep.?
Ensure brevity in your answer.  12.11. What is the difference between the highest and the lowest Rating index(maximum value in 2004 = 100) in Philippines?
Make the answer very short. 15.07. 